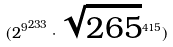Convert formula to latex. <formula><loc_0><loc_0><loc_500><loc_500>( { 2 ^ { 9 } } ^ { 2 3 3 } \cdot \sqrt { 2 6 5 } ^ { 4 1 5 } )</formula> 